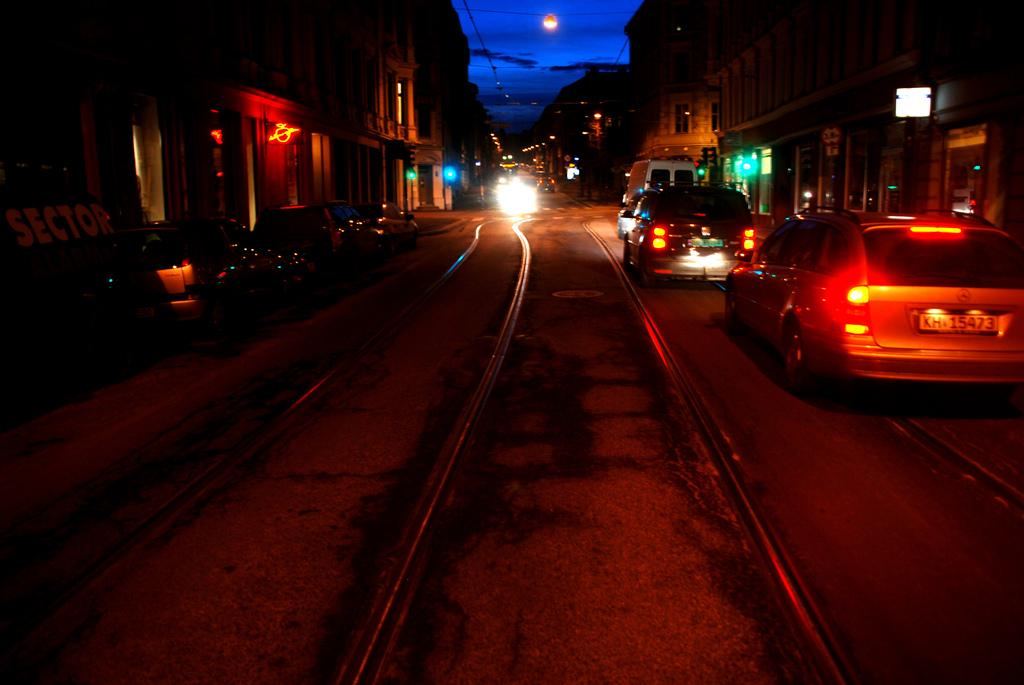What can be seen on the road in the image? There are vehicles on the road in the image. What structures are located beside the road? There are buildings beside the road in the image. What celestial body is visible in the image? The moon is visible in the image. How would you describe the sky in the image? The sky appears cloudy in the image. What type of spade is being used to invent a new lamp in the image? There is no spade or lamp present in the image, and no invention is taking place. 